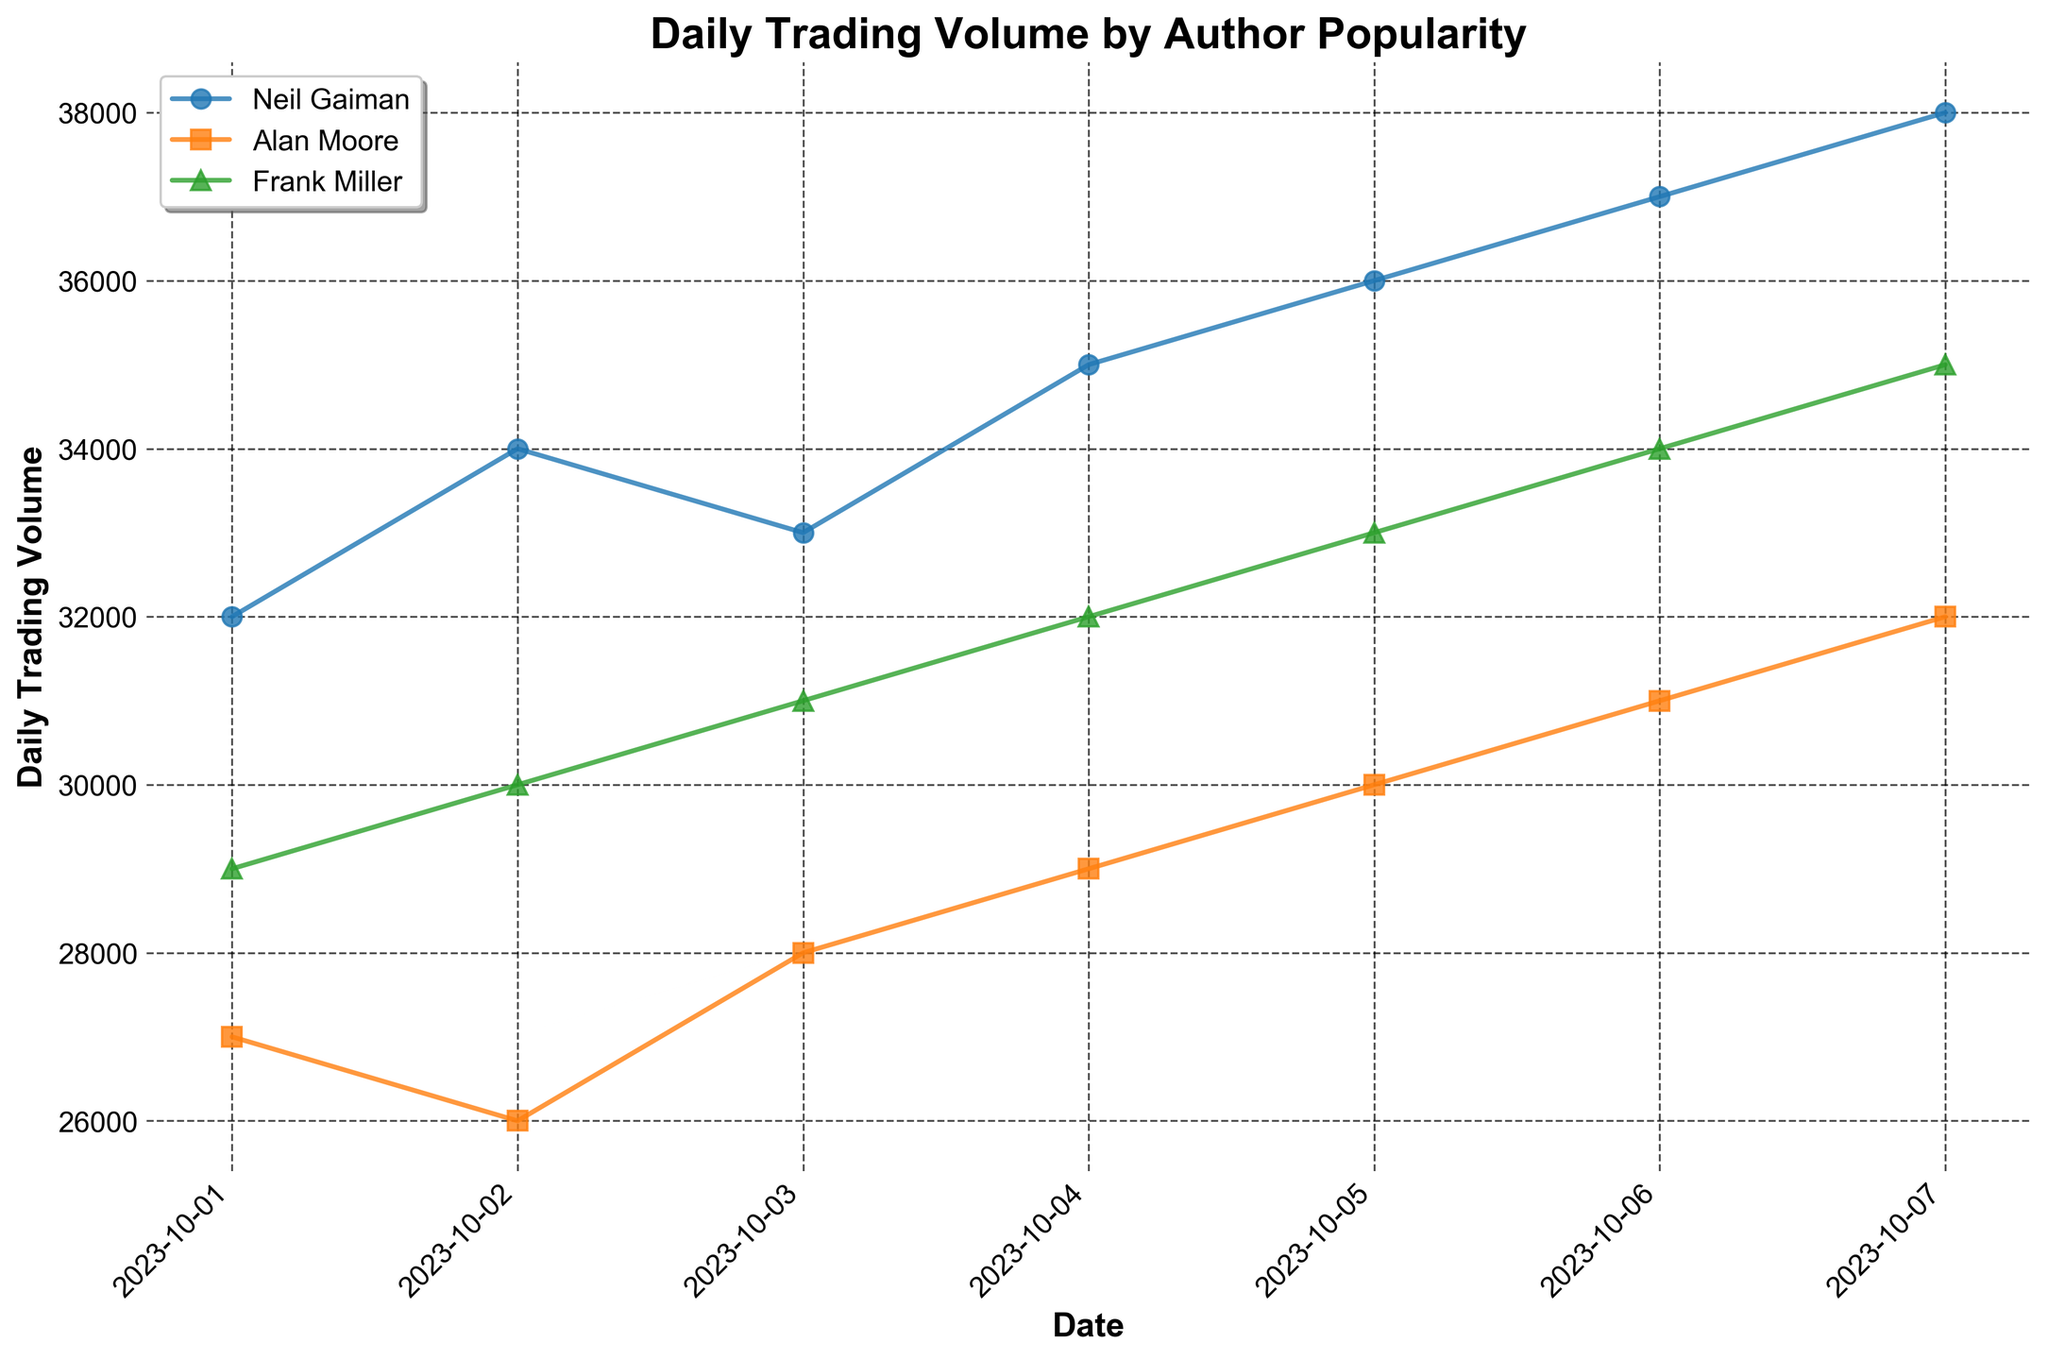What is the title of the plot? The title is typically displayed at the top center of the plot. From the data and code provided, we know the title is "Daily Trading Volume by Author Popularity".
Answer: Daily Trading Volume by Author Popularity What are the authors included in the plot? The plot includes three authors: Neil Gaiman, Alan Moore, and Frank Miller. These names were used to categorize the data in the 'Author Popularity' column.
Answer: Neil Gaiman, Alan Moore, Frank Miller How does the daily trading volume of Neil Gaiman compare on October 1st and October 7th? We look at the plot points corresponding to Neil Gaiman for October 1st and October 7th and compare their positions on the y-axis. From the figure, on October 1st, his volume is 32000, and on October 7th, it is 38000.
Answer: The volume increased from 32000 to 38000 What is the trend observed in Frank Miller's daily trading volume over the week? The plot for Frank Miller shows data points connected by a line. Observing the slope of these lines, it appears that the trading volume is steadily increasing each day.
Answer: An increasing trend Which author had the highest trading volume on October 3rd? Observing the specific date on the x-axis and corresponding points on the y-axis, Neil Gaiman had the highest trading volume on October 3rd with 33000.
Answer: Neil Gaiman On which date did Alan Moore have the lowest trading volume, and what was the volume? By looking for the lowest point for Alan Moore's line on the plot, the lowest trading volume was on October 2nd, with a volume of 26000.
Answer: October 2nd, 26000 Calculate the average daily trading volume for Frank Miller over the week. Sum Frank Miller's daily trading volumes (29000 + 30000 + 31000 + 32000 + 33000 + 34000 + 35000) and divide by the number of days (7). (29000 + 30000 + 31000 + 32000 + 33000 + 34000 + 35000) / 7 = 32428.57
Answer: 32428.57 Which author saw the greatest increase in daily trading volume from October 1st to October 7th? Calculate the difference for each author: 
Neil Gaiman: 38000 - 32000 = 6000
Alan Moore: 32000 - 27000 = 5000
Frank Miller: 35000 - 29000 = 6000
Both Neil Gaiman and Frank Miller saw the greatest increase of 6000.
Answer: Neil Gaiman and Frank Miller 